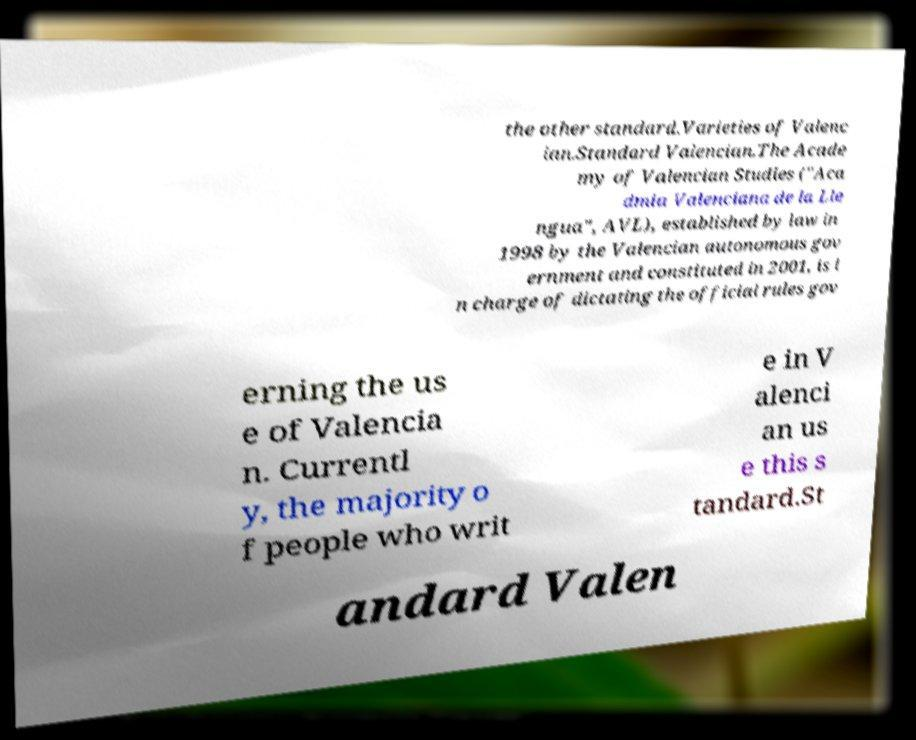For documentation purposes, I need the text within this image transcribed. Could you provide that? the other standard.Varieties of Valenc ian.Standard Valencian.The Acade my of Valencian Studies ("Aca dmia Valenciana de la Lle ngua", AVL), established by law in 1998 by the Valencian autonomous gov ernment and constituted in 2001, is i n charge of dictating the official rules gov erning the us e of Valencia n. Currentl y, the majority o f people who writ e in V alenci an us e this s tandard.St andard Valen 